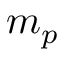Convert formula to latex. <formula><loc_0><loc_0><loc_500><loc_500>m _ { p }</formula> 